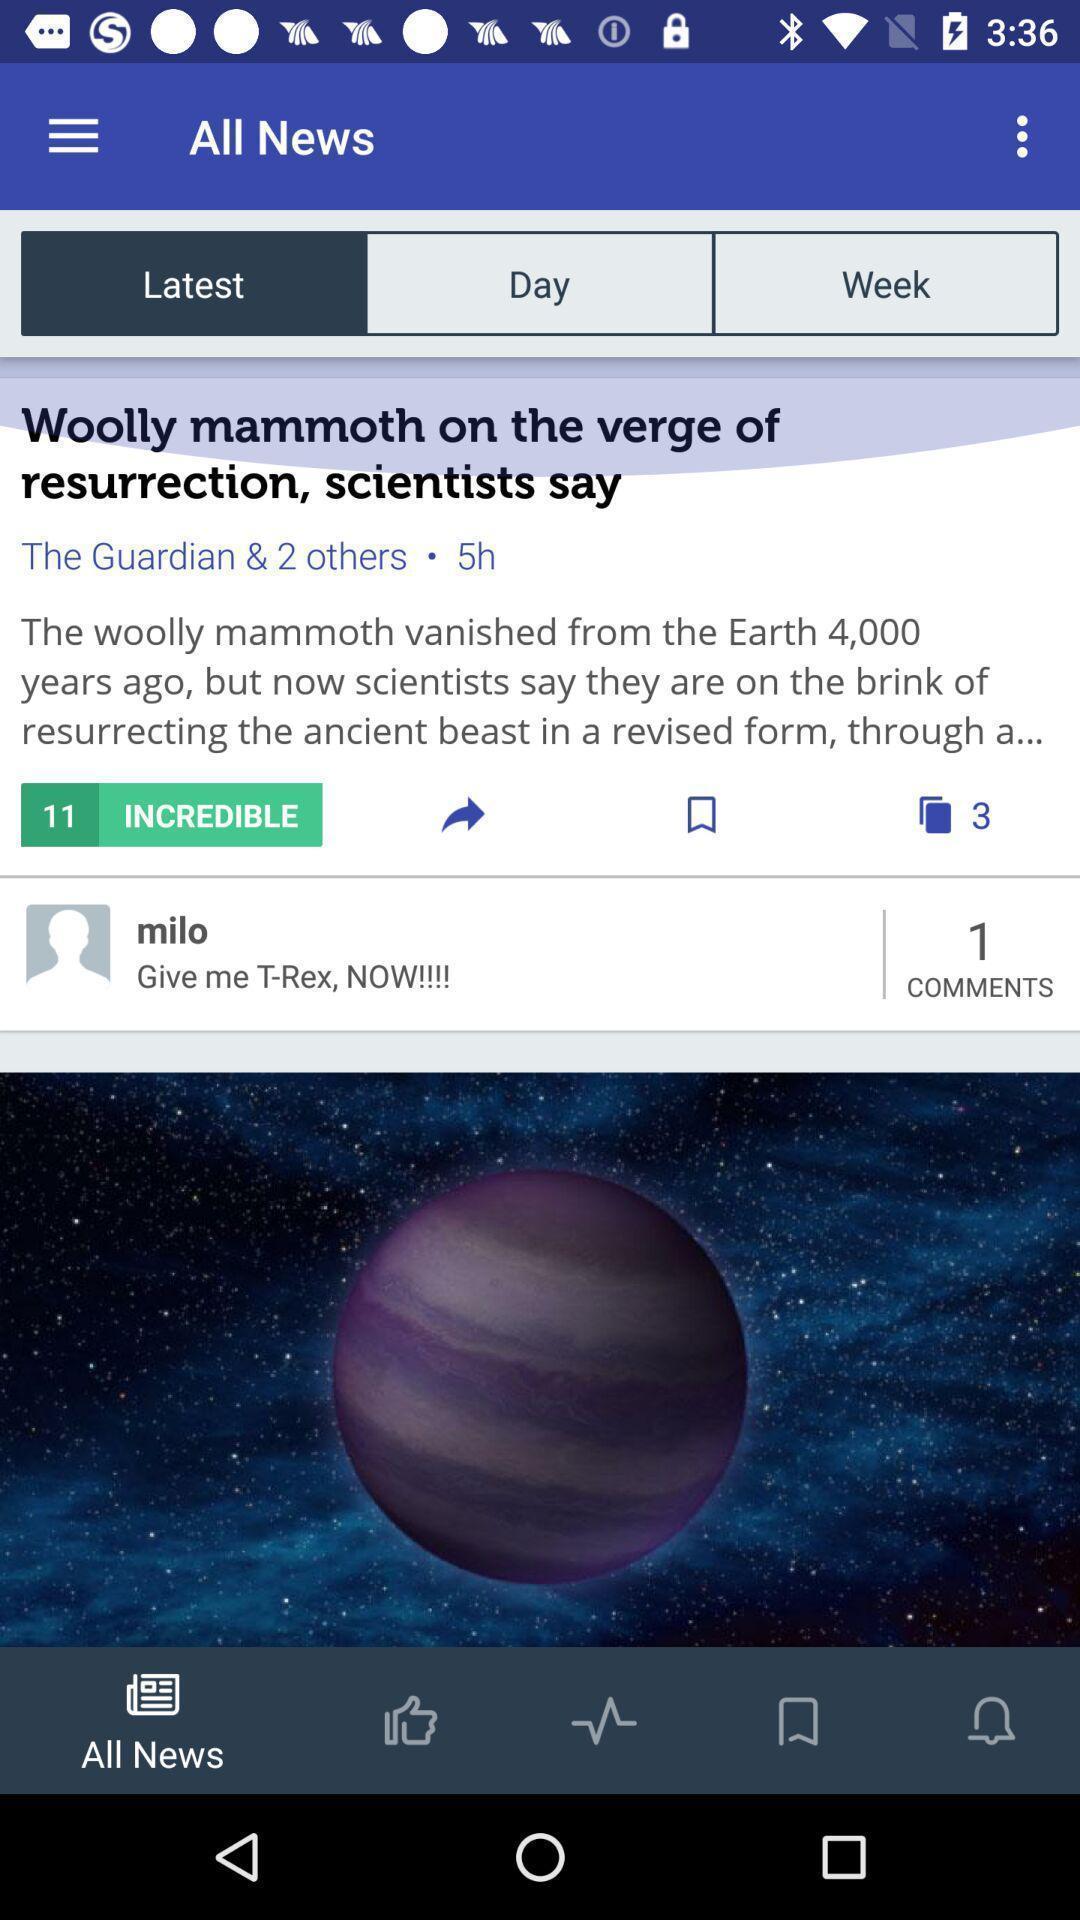What details can you identify in this image? Page showing latest news in the news app. 